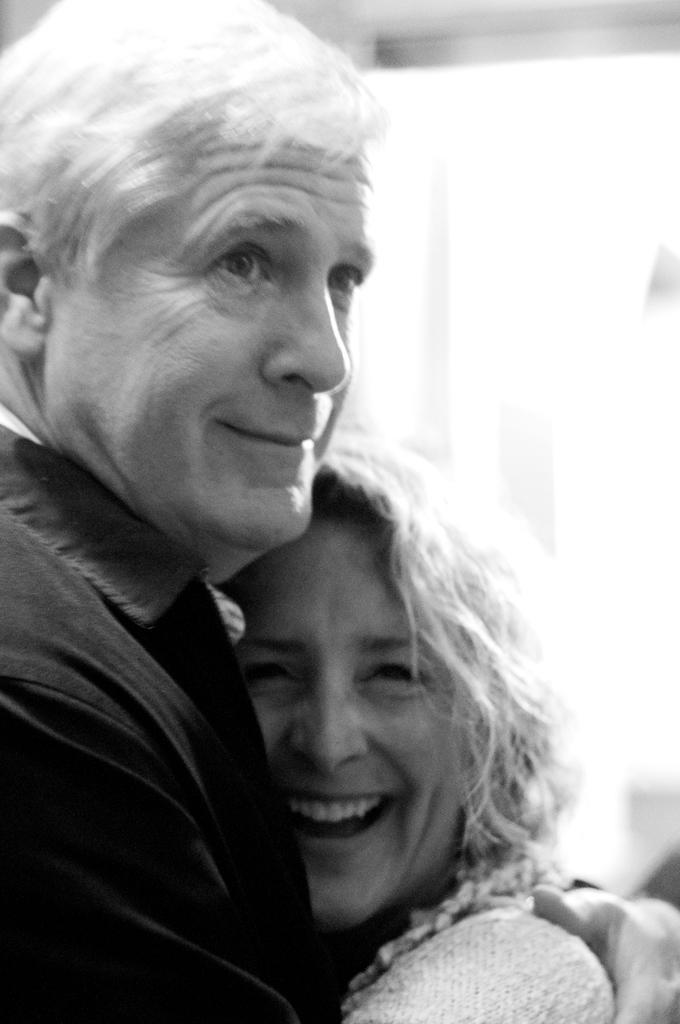Could you give a brief overview of what you see in this image? A couple is wearing clothes and hugging each other. 